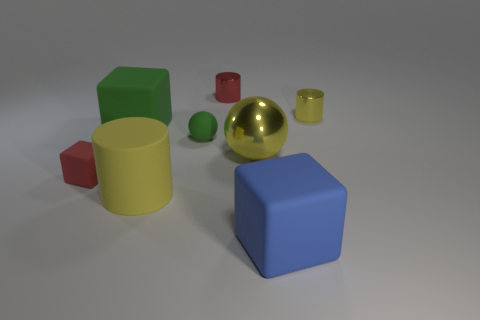Add 2 blocks. How many objects exist? 10 Subtract all cylinders. How many objects are left? 5 Subtract 0 cyan cubes. How many objects are left? 8 Subtract all spheres. Subtract all small green objects. How many objects are left? 5 Add 2 large yellow cylinders. How many large yellow cylinders are left? 3 Add 7 big cyan balls. How many big cyan balls exist? 7 